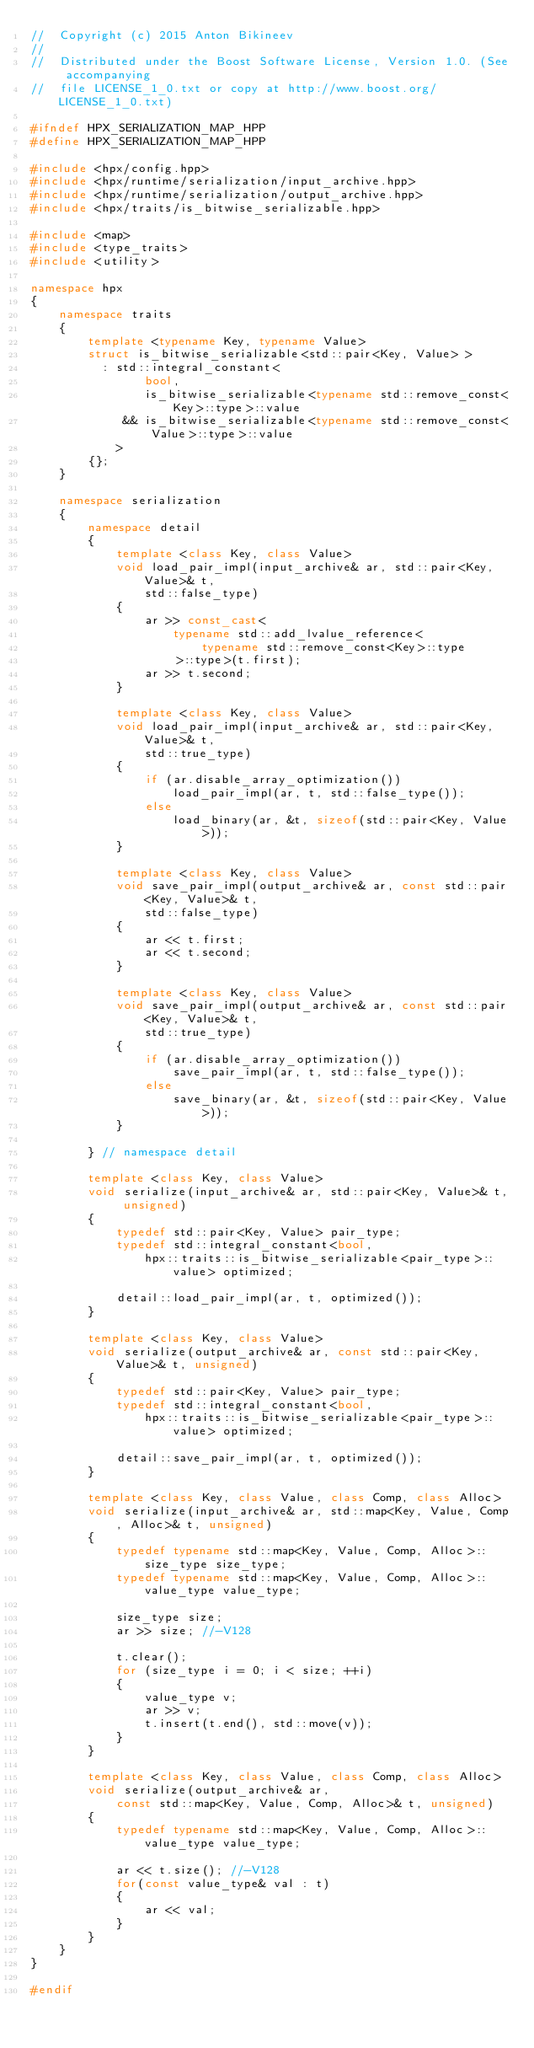Convert code to text. <code><loc_0><loc_0><loc_500><loc_500><_C++_>//  Copyright (c) 2015 Anton Bikineev
//
//  Distributed under the Boost Software License, Version 1.0. (See accompanying
//  file LICENSE_1_0.txt or copy at http://www.boost.org/LICENSE_1_0.txt)

#ifndef HPX_SERIALIZATION_MAP_HPP
#define HPX_SERIALIZATION_MAP_HPP

#include <hpx/config.hpp>
#include <hpx/runtime/serialization/input_archive.hpp>
#include <hpx/runtime/serialization/output_archive.hpp>
#include <hpx/traits/is_bitwise_serializable.hpp>

#include <map>
#include <type_traits>
#include <utility>

namespace hpx
{
    namespace traits
    {
        template <typename Key, typename Value>
        struct is_bitwise_serializable<std::pair<Key, Value> >
          : std::integral_constant<
                bool,
                is_bitwise_serializable<typename std::remove_const<Key>::type>::value
             && is_bitwise_serializable<typename std::remove_const<Value>::type>::value
            >
        {};
    }

    namespace serialization
    {
        namespace detail
        {
            template <class Key, class Value>
            void load_pair_impl(input_archive& ar, std::pair<Key, Value>& t,
                std::false_type)
            {
                ar >> const_cast<
                    typename std::add_lvalue_reference<
                        typename std::remove_const<Key>::type
                    >::type>(t.first);
                ar >> t.second;
            }

            template <class Key, class Value>
            void load_pair_impl(input_archive& ar, std::pair<Key, Value>& t,
                std::true_type)
            {
                if (ar.disable_array_optimization())
                    load_pair_impl(ar, t, std::false_type());
                else
                    load_binary(ar, &t, sizeof(std::pair<Key, Value>));
            }

            template <class Key, class Value>
            void save_pair_impl(output_archive& ar, const std::pair<Key, Value>& t,
                std::false_type)
            {
                ar << t.first;
                ar << t.second;
            }

            template <class Key, class Value>
            void save_pair_impl(output_archive& ar, const std::pair<Key, Value>& t,
                std::true_type)
            {
                if (ar.disable_array_optimization())
                    save_pair_impl(ar, t, std::false_type());
                else
                    save_binary(ar, &t, sizeof(std::pair<Key, Value>));
            }

        } // namespace detail

        template <class Key, class Value>
        void serialize(input_archive& ar, std::pair<Key, Value>& t, unsigned)
        {
            typedef std::pair<Key, Value> pair_type;
            typedef std::integral_constant<bool,
                hpx::traits::is_bitwise_serializable<pair_type>::value> optimized;

            detail::load_pair_impl(ar, t, optimized());
        }

        template <class Key, class Value>
        void serialize(output_archive& ar, const std::pair<Key, Value>& t, unsigned)
        {
            typedef std::pair<Key, Value> pair_type;
            typedef std::integral_constant<bool,
                hpx::traits::is_bitwise_serializable<pair_type>::value> optimized;

            detail::save_pair_impl(ar, t, optimized());
        }

        template <class Key, class Value, class Comp, class Alloc>
        void serialize(input_archive& ar, std::map<Key, Value, Comp, Alloc>& t, unsigned)
        {
            typedef typename std::map<Key, Value, Comp, Alloc>::size_type size_type;
            typedef typename std::map<Key, Value, Comp, Alloc>::value_type value_type;

            size_type size;
            ar >> size; //-V128

            t.clear();
            for (size_type i = 0; i < size; ++i)
            {
                value_type v;
                ar >> v;
                t.insert(t.end(), std::move(v));
            }
        }

        template <class Key, class Value, class Comp, class Alloc>
        void serialize(output_archive& ar,
            const std::map<Key, Value, Comp, Alloc>& t, unsigned)
        {
            typedef typename std::map<Key, Value, Comp, Alloc>::value_type value_type;

            ar << t.size(); //-V128
            for(const value_type& val : t)
            {
                ar << val;
            }
        }
    }
}

#endif
</code> 